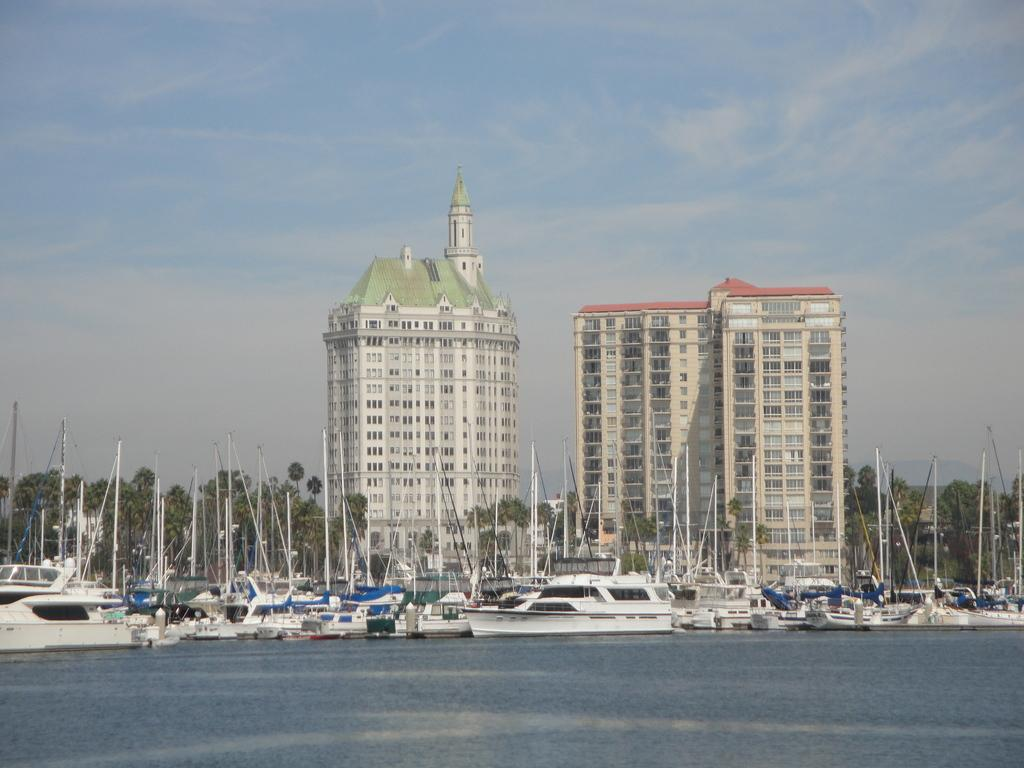What type of vehicles are in the image? There are ships in the image. image. What is the color of the ships? The ships are white in color. Where are the ships located in the image? The ships are on the surface of the water. What can be seen in the background of the image? There are trees, buildings, and the sky visible in the background of the image. Can you see an ant swimming in the water near the ships? There is no ant or swimming activity present in the image; it features ships on the water's surface. 